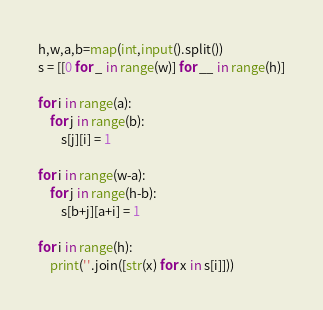<code> <loc_0><loc_0><loc_500><loc_500><_Python_>h,w,a,b=map(int,input().split())
s = [[0 for _ in range(w)] for __ in range(h)]

for i in range(a):
    for j in range(b):
        s[j][i] = 1

for i in range(w-a):
    for j in range(h-b):
        s[b+j][a+i] = 1

for i in range(h):
    print(''.join([str(x) for x in s[i]]))</code> 